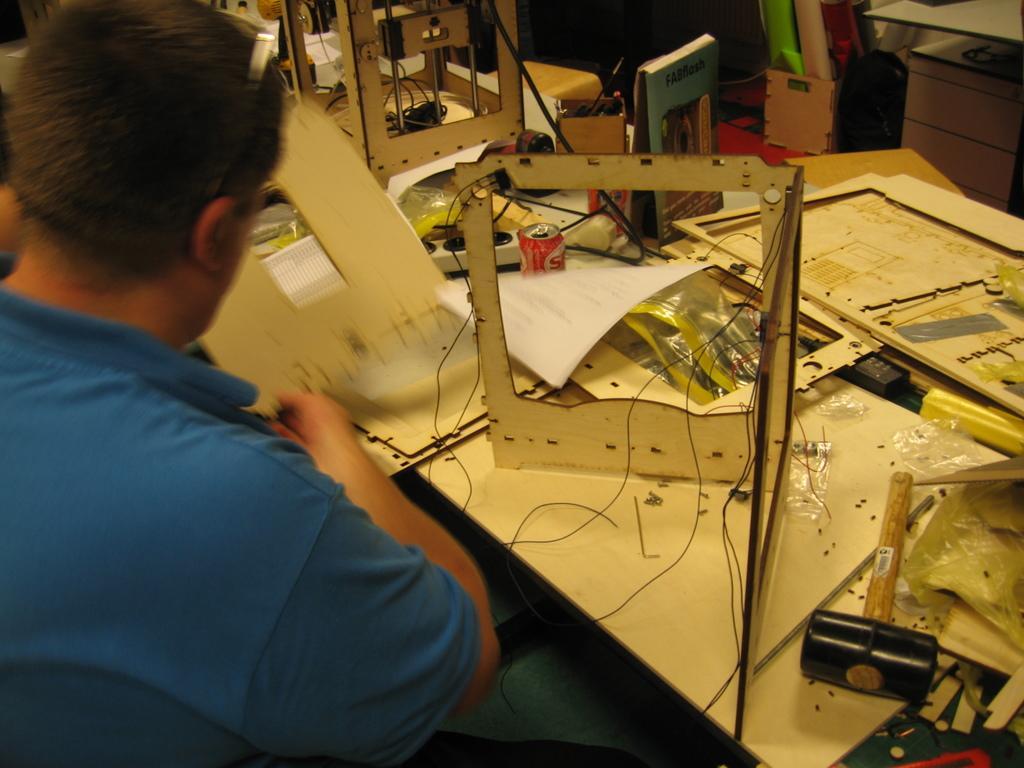In one or two sentences, can you explain what this image depicts? In this image on the left side there is one person who is sitting in front of him there is a table. On the table there is a hammer, coke container, papers, wires and some charts, boards and some other objects. In the background there is a table and some charts. 